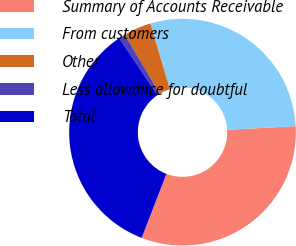<chart> <loc_0><loc_0><loc_500><loc_500><pie_chart><fcel>Summary of Accounts Receivable<fcel>From customers<fcel>Other<fcel>Less allowance for doubtful<fcel>Total<nl><fcel>31.71%<fcel>28.73%<fcel>3.92%<fcel>0.94%<fcel>34.69%<nl></chart> 